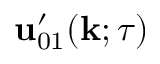Convert formula to latex. <formula><loc_0><loc_0><loc_500><loc_500>{ u } _ { 0 1 } ^ { \prime } ( { k } ; \tau )</formula> 